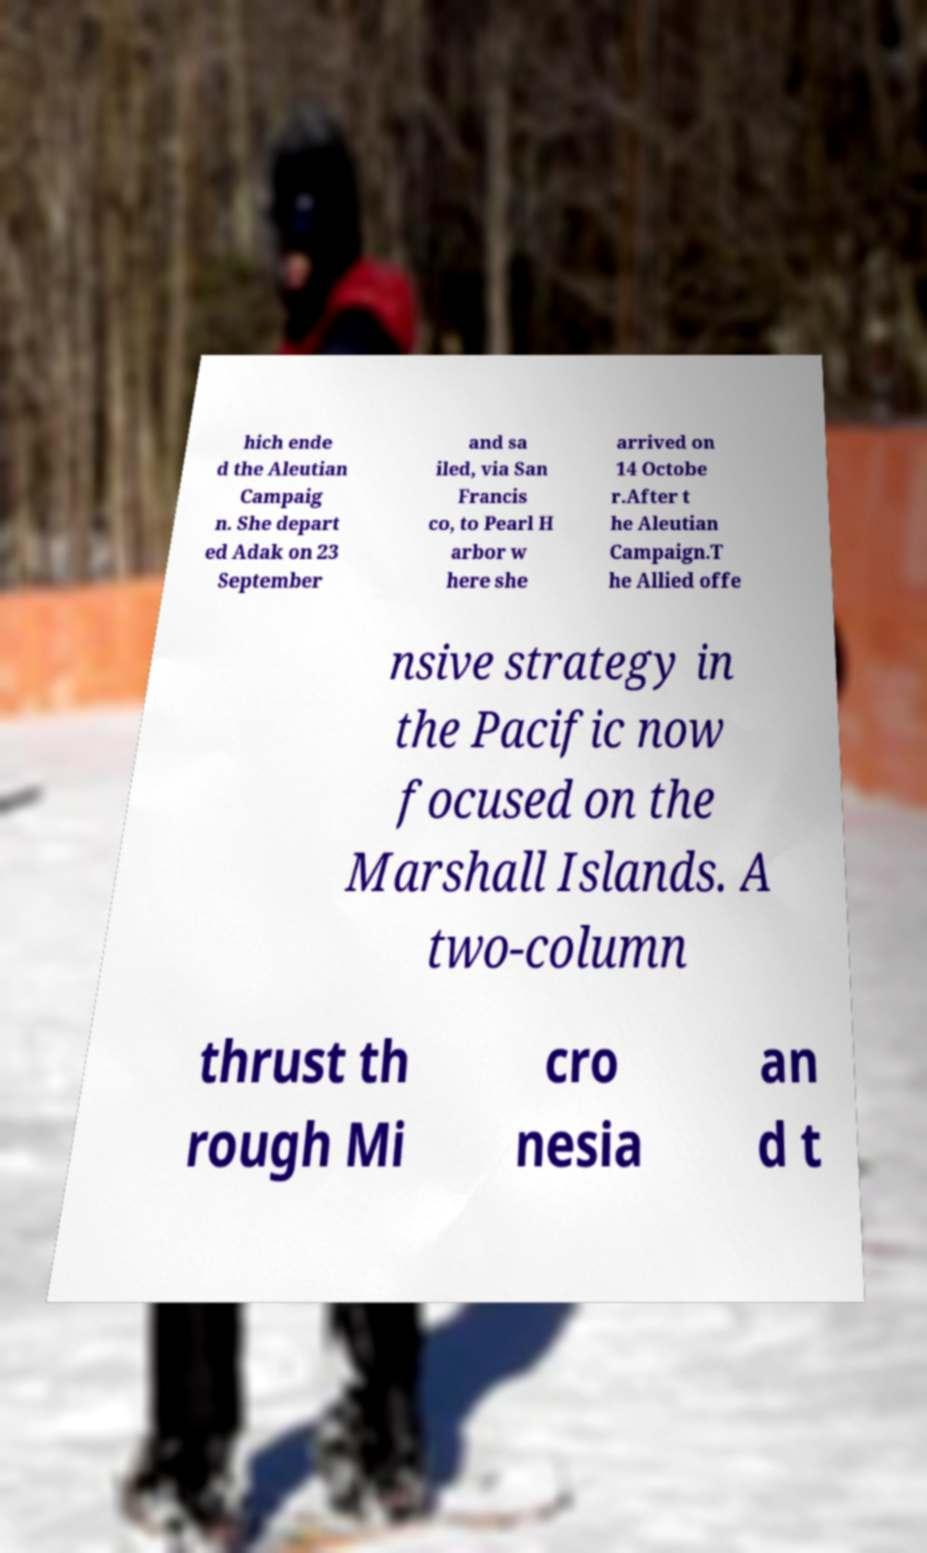Could you extract and type out the text from this image? hich ende d the Aleutian Campaig n. She depart ed Adak on 23 September and sa iled, via San Francis co, to Pearl H arbor w here she arrived on 14 Octobe r.After t he Aleutian Campaign.T he Allied offe nsive strategy in the Pacific now focused on the Marshall Islands. A two-column thrust th rough Mi cro nesia an d t 